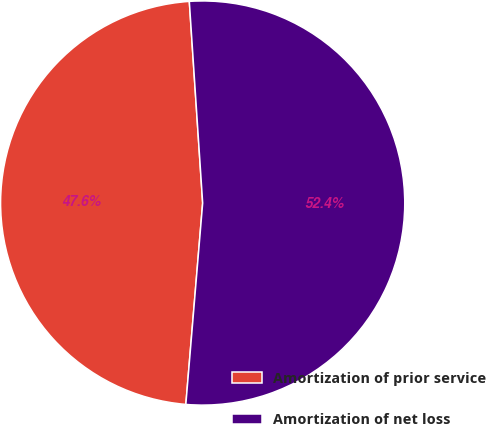Convert chart to OTSL. <chart><loc_0><loc_0><loc_500><loc_500><pie_chart><fcel>Amortization of prior service<fcel>Amortization of net loss<nl><fcel>47.62%<fcel>52.38%<nl></chart> 